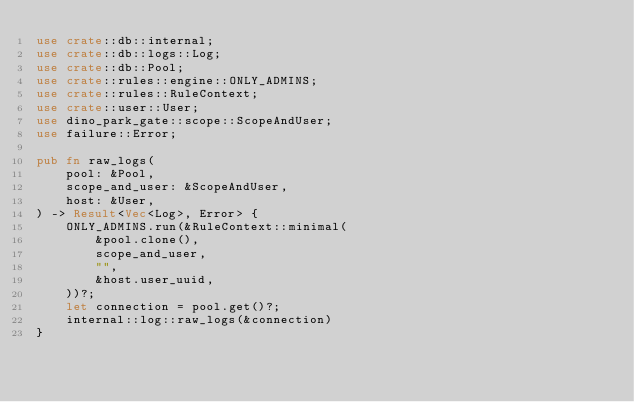Convert code to text. <code><loc_0><loc_0><loc_500><loc_500><_Rust_>use crate::db::internal;
use crate::db::logs::Log;
use crate::db::Pool;
use crate::rules::engine::ONLY_ADMINS;
use crate::rules::RuleContext;
use crate::user::User;
use dino_park_gate::scope::ScopeAndUser;
use failure::Error;

pub fn raw_logs(
    pool: &Pool,
    scope_and_user: &ScopeAndUser,
    host: &User,
) -> Result<Vec<Log>, Error> {
    ONLY_ADMINS.run(&RuleContext::minimal(
        &pool.clone(),
        scope_and_user,
        "",
        &host.user_uuid,
    ))?;
    let connection = pool.get()?;
    internal::log::raw_logs(&connection)
}
</code> 